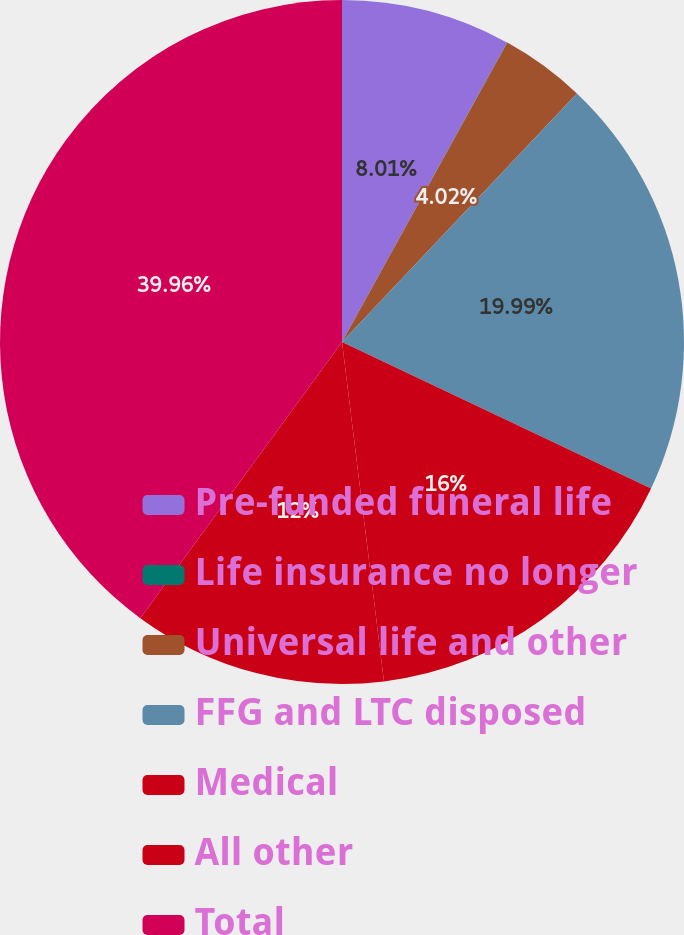Convert chart. <chart><loc_0><loc_0><loc_500><loc_500><pie_chart><fcel>Pre-funded funeral life<fcel>Life insurance no longer<fcel>Universal life and other<fcel>FFG and LTC disposed<fcel>Medical<fcel>All other<fcel>Total<nl><fcel>8.01%<fcel>0.02%<fcel>4.02%<fcel>19.99%<fcel>16.0%<fcel>12.0%<fcel>39.96%<nl></chart> 